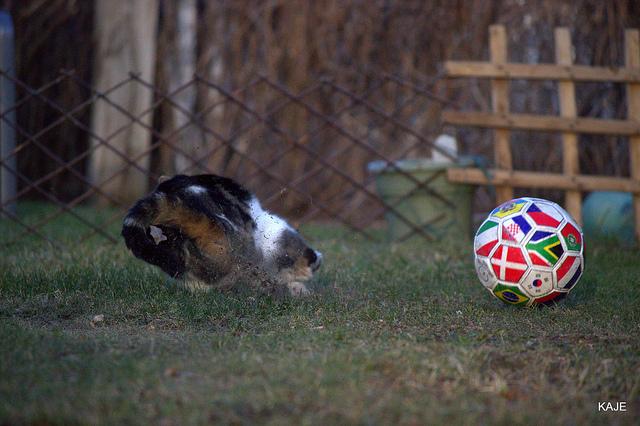What type of ball is this?
Keep it brief. Soccer. What is being displayed on the pentagons of the ball?
Short answer required. Flags. What is on the fence?
Answer briefly. Cat. 